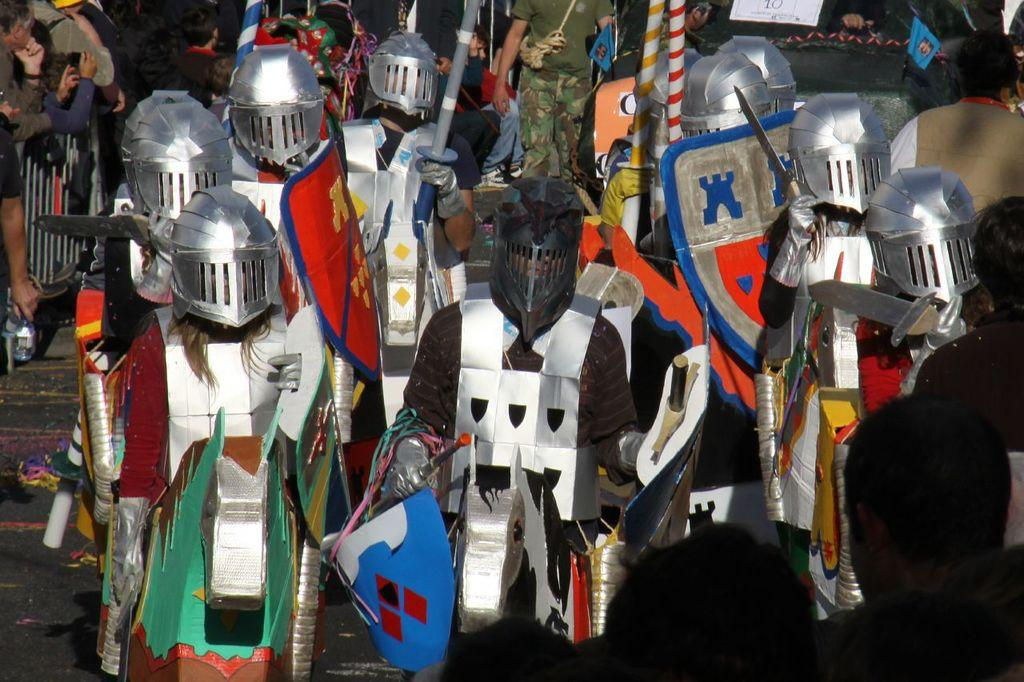How many people are in the image? There is a group of people in the image. Where are the people located in the image? The people are standing on the road. What type of clothing are some of the people wearing? Some people are wearing warrior costumes. What protective gear are some of the people wearing? Some people are wearing helmets. What weapons are some of the people holding? Some people are holding swords. What defensive tools are some of the people holding? Some people are holding shields. What type of seed is being planted by the people in the image? There is no seed or planting activity depicted in the image; the people are wearing warrior costumes and holding weapons and shields. 